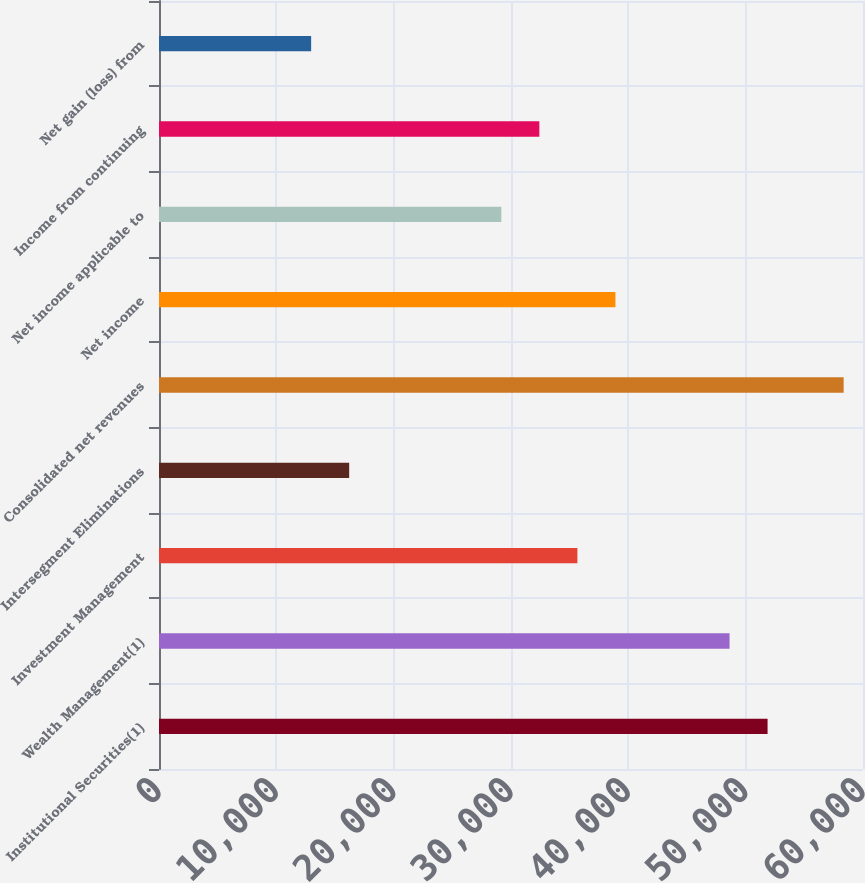Convert chart to OTSL. <chart><loc_0><loc_0><loc_500><loc_500><bar_chart><fcel>Institutional Securities(1)<fcel>Wealth Management(1)<fcel>Investment Management<fcel>Intersegment Eliminations<fcel>Consolidated net revenues<fcel>Net income<fcel>Net income applicable to<fcel>Income from continuing<fcel>Net gain (loss) from<nl><fcel>51867.2<fcel>48625.5<fcel>35658.7<fcel>16208.5<fcel>58350.6<fcel>38900.4<fcel>29175.3<fcel>32417<fcel>12966.8<nl></chart> 